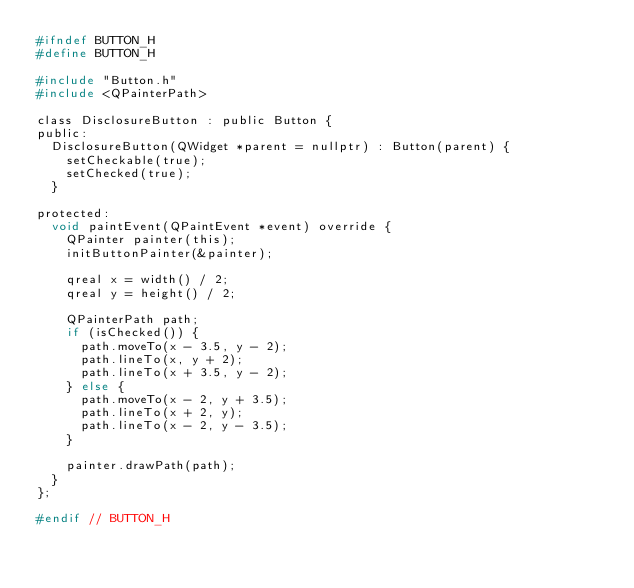<code> <loc_0><loc_0><loc_500><loc_500><_C_>#ifndef BUTTON_H
#define BUTTON_H

#include "Button.h"
#include <QPainterPath>

class DisclosureButton : public Button {
public:
  DisclosureButton(QWidget *parent = nullptr) : Button(parent) {
    setCheckable(true);
    setChecked(true);
  }

protected:
  void paintEvent(QPaintEvent *event) override {
    QPainter painter(this);
    initButtonPainter(&painter);

    qreal x = width() / 2;
    qreal y = height() / 2;

    QPainterPath path;
    if (isChecked()) {
      path.moveTo(x - 3.5, y - 2);
      path.lineTo(x, y + 2);
      path.lineTo(x + 3.5, y - 2);
    } else {
      path.moveTo(x - 2, y + 3.5);
      path.lineTo(x + 2, y);
      path.lineTo(x - 2, y - 3.5);
    }

    painter.drawPath(path);
  }
};

#endif // BUTTON_H
</code> 